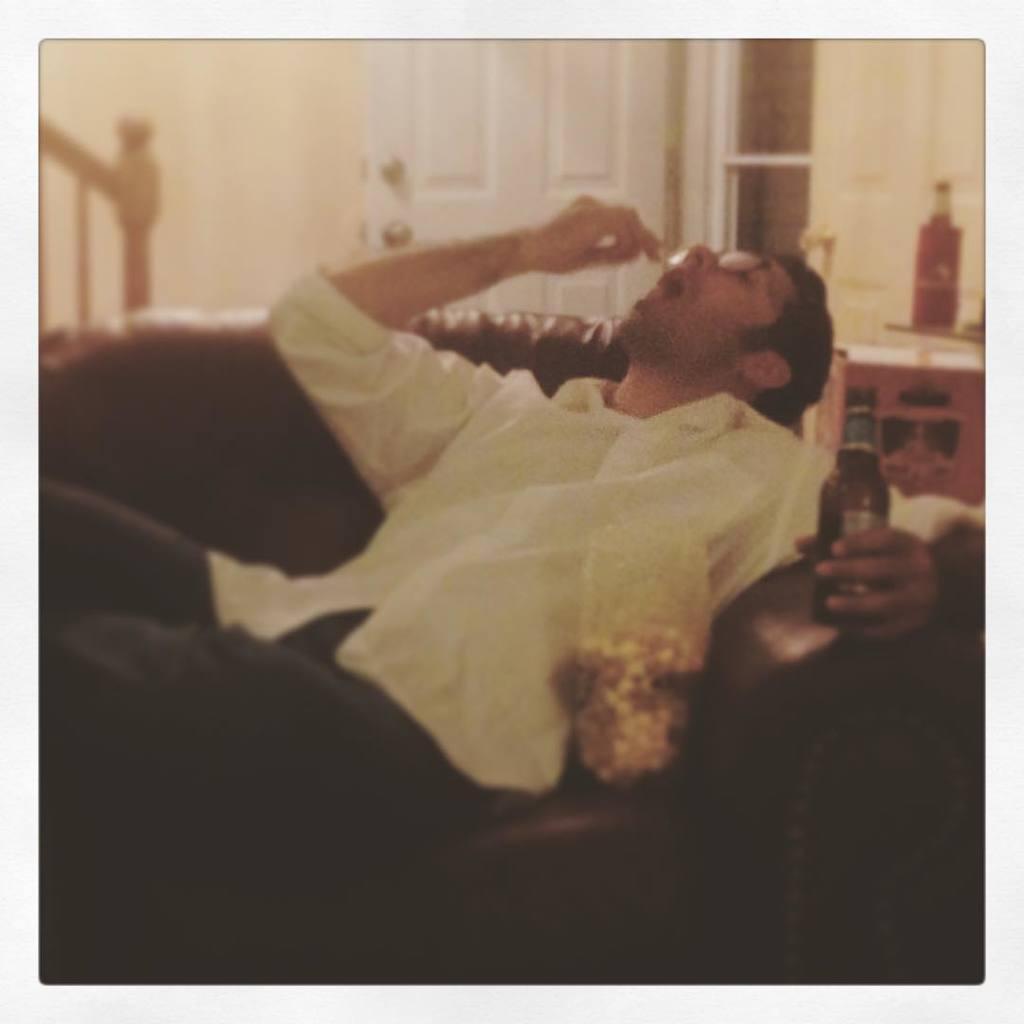How would you summarize this image in a sentence or two? In this image person is sitting on the sofa by holding the bottle. Beside him there is a popcorn. At the back side there are stairs, door and we can see a table and on top of it there is a bottle. 